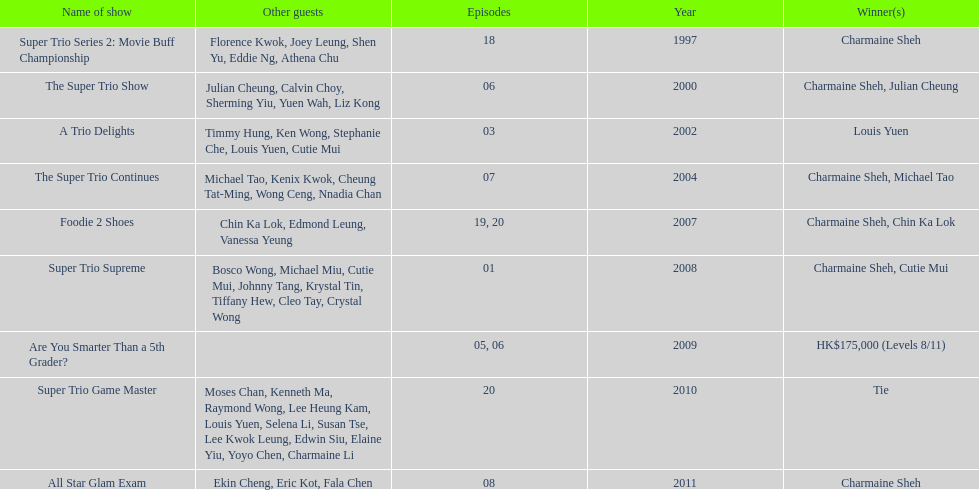What is the number of other guests in the 2002 show "a trio delights"? 5. 